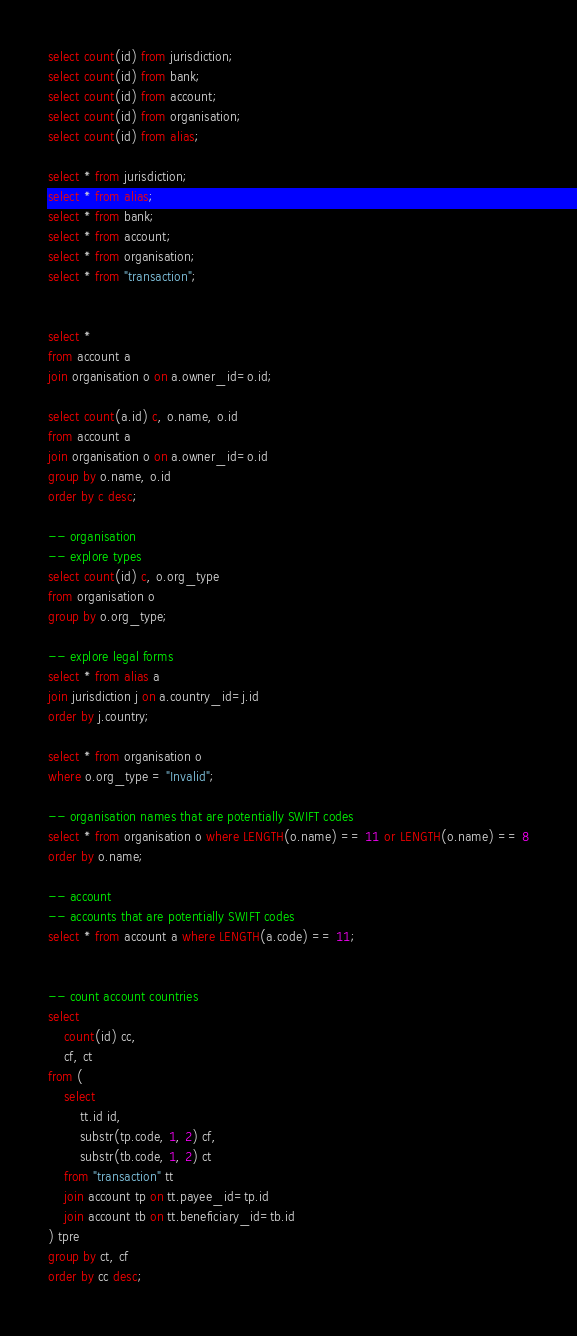<code> <loc_0><loc_0><loc_500><loc_500><_SQL_>select count(id) from jurisdiction;
select count(id) from bank;
select count(id) from account;
select count(id) from organisation;
select count(id) from alias;

select * from jurisdiction;
select * from alias;
select * from bank;
select * from account;
select * from organisation;
select * from "transaction";


select *
from account a
join organisation o on a.owner_id=o.id;

select count(a.id) c, o.name, o.id
from account a
join organisation o on a.owner_id=o.id
group by o.name, o.id
order by c desc;

-- organisation
-- explore types
select count(id) c, o.org_type
from organisation o
group by o.org_type;

-- explore legal forms
select * from alias a
join jurisdiction j on a.country_id=j.id
order by j.country;

select * from organisation o
where o.org_type = "Invalid";

-- organisation names that are potentially SWIFT codes
select * from organisation o where LENGTH(o.name) == 11 or LENGTH(o.name) == 8
order by o.name;

-- account
-- accounts that are potentially SWIFT codes
select * from account a where LENGTH(a.code) == 11;


-- count account countries
select
	count(id) cc,
	cf, ct
from (
	select
	    tt.id id,
		substr(tp.code, 1, 2) cf,
		substr(tb.code, 1, 2) ct
	from "transaction" tt
	join account tp on tt.payee_id=tp.id
	join account tb on tt.beneficiary_id=tb.id
) tpre
group by ct, cf
order by cc desc;
</code> 